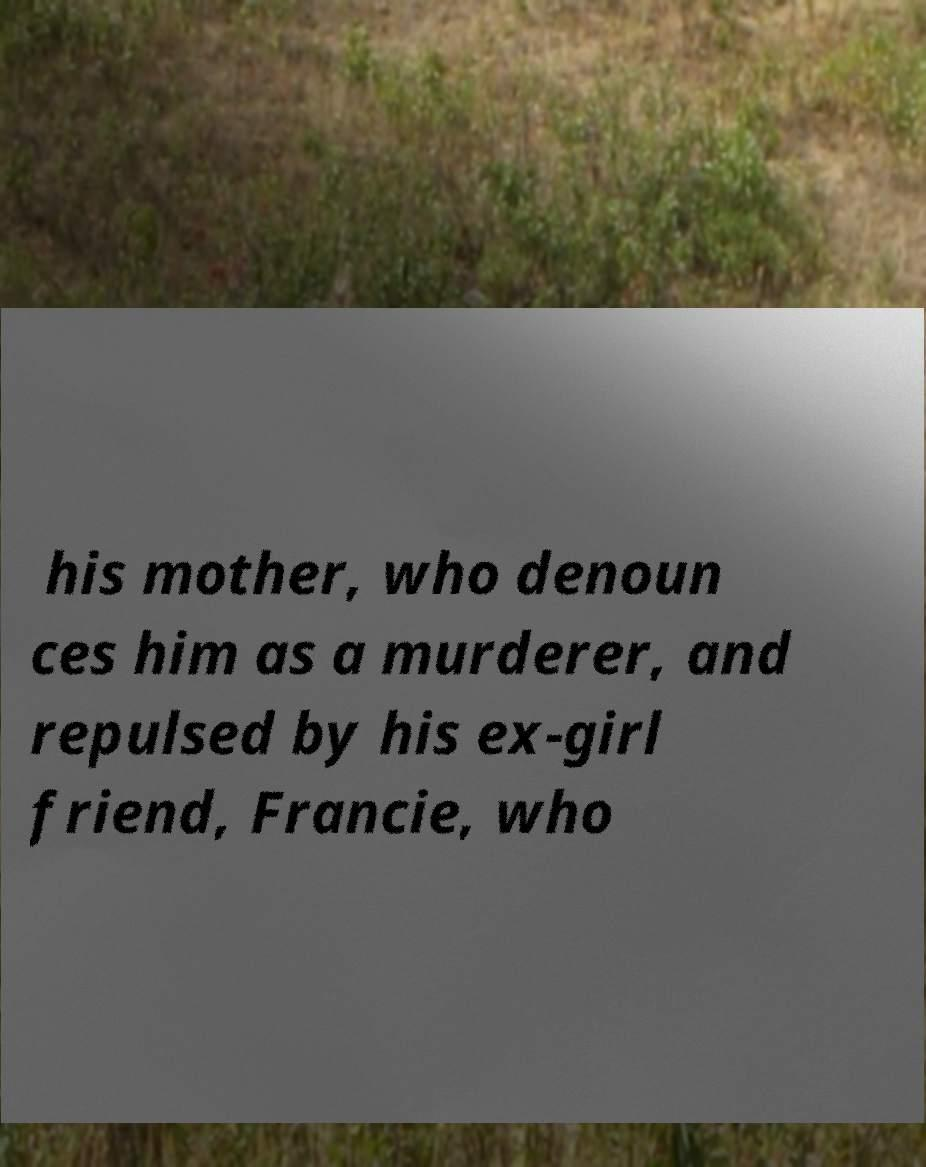What messages or text are displayed in this image? I need them in a readable, typed format. his mother, who denoun ces him as a murderer, and repulsed by his ex-girl friend, Francie, who 